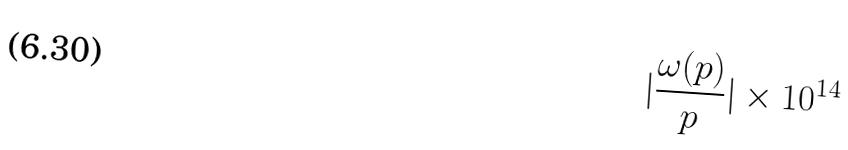<formula> <loc_0><loc_0><loc_500><loc_500>| \frac { \omega ( p ) } { p } | \times 1 0 ^ { 1 4 }</formula> 